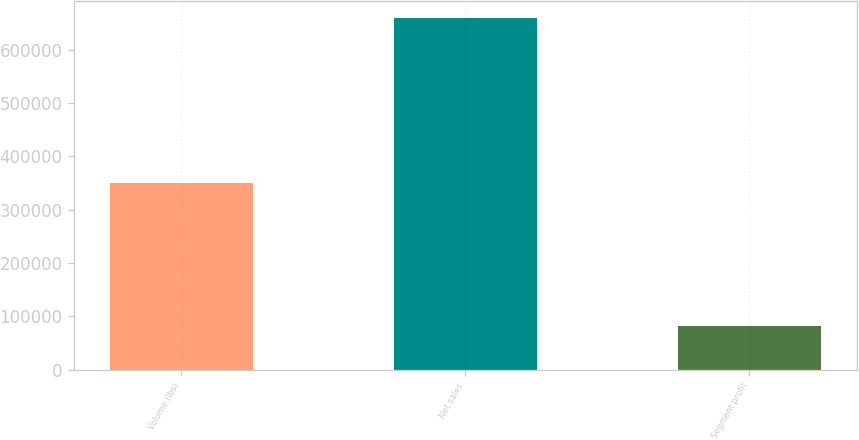Convert chart to OTSL. <chart><loc_0><loc_0><loc_500><loc_500><bar_chart><fcel>Volume (lbs)<fcel>Net sales<fcel>Segment profit<nl><fcel>350399<fcel>658845<fcel>81582<nl></chart> 